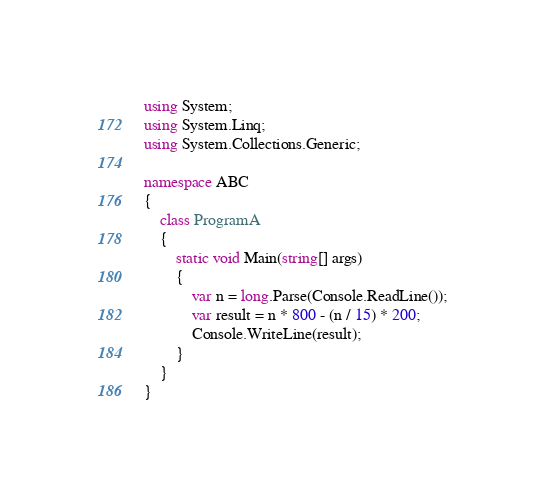Convert code to text. <code><loc_0><loc_0><loc_500><loc_500><_C#_>using System;
using System.Linq;
using System.Collections.Generic;

namespace ABC
{
    class ProgramA
    {
        static void Main(string[] args)
        {
            var n = long.Parse(Console.ReadLine());
            var result = n * 800 - (n / 15) * 200;
            Console.WriteLine(result);
        }
    }
}
</code> 